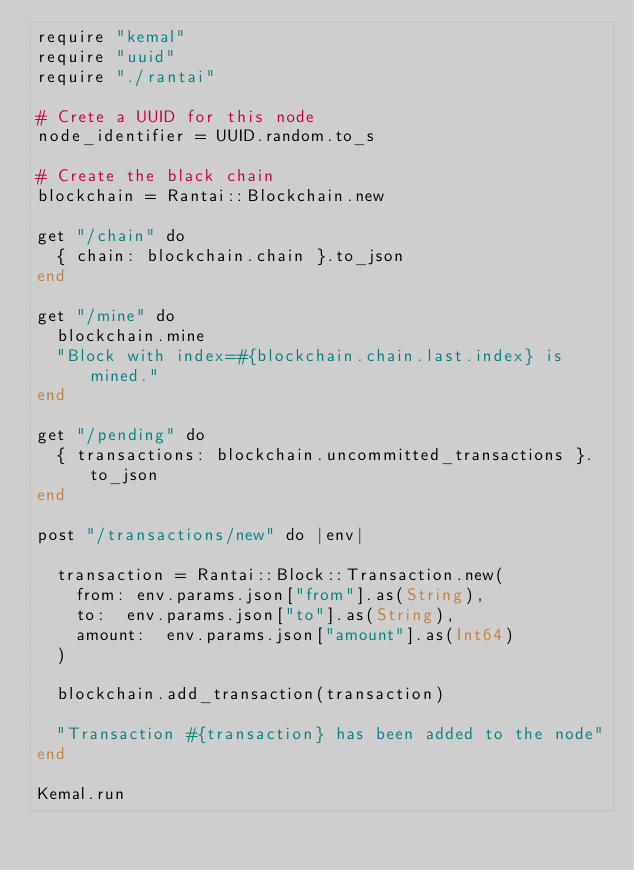Convert code to text. <code><loc_0><loc_0><loc_500><loc_500><_Crystal_>require "kemal"
require "uuid"
require "./rantai"

# Crete a UUID for this node
node_identifier = UUID.random.to_s

# Create the black chain
blockchain = Rantai::Blockchain.new

get "/chain" do
  { chain: blockchain.chain }.to_json
end

get "/mine" do
  blockchain.mine
  "Block with index=#{blockchain.chain.last.index} is mined."
end

get "/pending" do
  { transactions: blockchain.uncommitted_transactions }.to_json
end

post "/transactions/new" do |env|

  transaction = Rantai::Block::Transaction.new(
    from: env.params.json["from"].as(String),
    to:  env.params.json["to"].as(String),
    amount:  env.params.json["amount"].as(Int64)
  )

  blockchain.add_transaction(transaction)

  "Transaction #{transaction} has been added to the node"
end

Kemal.run</code> 